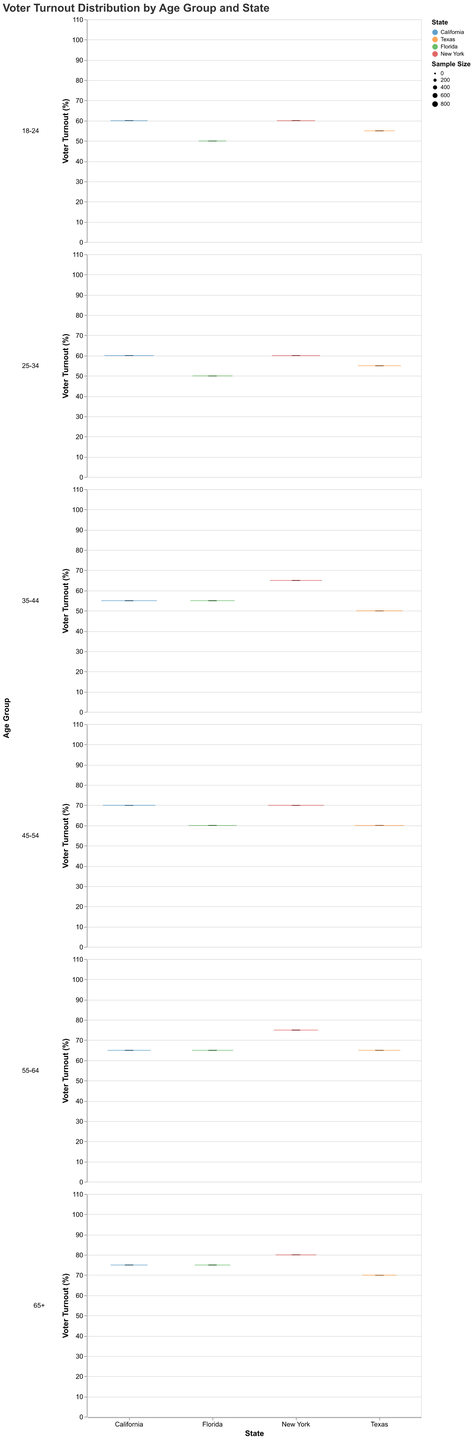Which state has the highest maximum turnout in the 65+ age group? In the New York row for the 65+ age group, the maximum turnout value is indicated at 105%, which is higher than the other states' maximum values in the same age group.
Answer: New York What is the median voter turnout for the 25-34 age group in Florida? Refer to the Florida row for the 25-34 age group, where the median turnout is listed as 50%.
Answer: 50% How does the median turnout of the 18-24 age group in Texas compare to California? For Texas, the median turnout in the 18-24 age group is 55%. For California, it is also 60%. Comparing these, Texas has a lower median turnout than California.
Answer: Lower Which state shows the widest range in voter turnout for the 45-54 age group? For the 45-54 age group, the difference between the max and min turnout in each state is: California (95-50=45), Texas (90-35=55), Florida (95-35=60), New York (95-45=50). Florida has the widest range.
Answer: Florida What's the median voter turnout for the age group with the smallest sample size in California? The smallest sample size in California is for the 18-24 and 65+ age groups, both with a count of 500. The median voter turnouts are 60% for the 18-24 age group and 75% for the 65+ age group, so the 18-24 group has the smallest sample size with a median of 60%.
Answer: 60% Which state has the highest median voter turnout in the 55-64 age group? For the 55-64 age group, the median turnouts are: California (65%), Texas (65%), Florida (65%), and New York (75%). New York has the highest median turnout.
Answer: New York What is the interquartile range (IQR) of voter turnout for the 35-44 age group in Texas? The IQR is calculated as the 3rd quartile minus the 1st quartile. For the 35-44 age group in Texas, 1st quartile = 40% and 3rd quartile = 65%, so the IQR is 65% - 40% = 25%.
Answer: 25% Which state exhibits the highest variability in voter turnout within the 55-64 age group? Variability can be measured by the range between the max and min turnout values. For the 55-64 age group: California (85-45=40), Texas (85-40=45), Florida (90-40=50), New York (100-50=50). Florida and New York both exhibit the highest variability with a range of 50%.
Answer: Florida and New York 